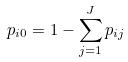Convert formula to latex. <formula><loc_0><loc_0><loc_500><loc_500>p _ { i 0 } = 1 - \sum _ { j = 1 } ^ { J } p _ { i j }</formula> 